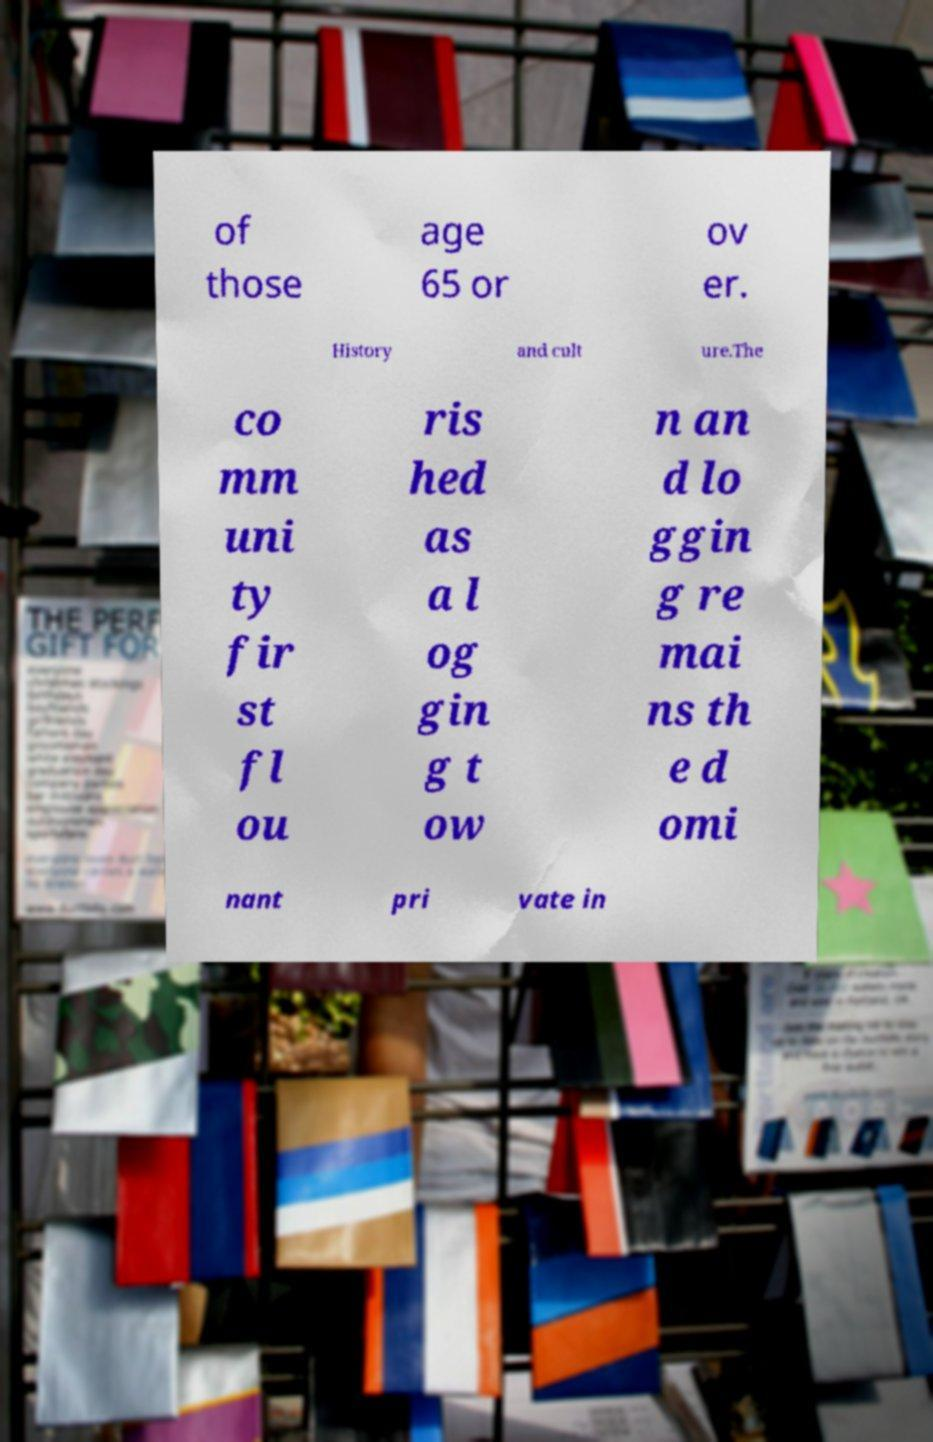Could you extract and type out the text from this image? of those age 65 or ov er. History and cult ure.The co mm uni ty fir st fl ou ris hed as a l og gin g t ow n an d lo ggin g re mai ns th e d omi nant pri vate in 